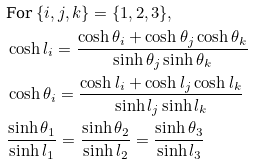<formula> <loc_0><loc_0><loc_500><loc_500>& \text {For} \ \{ i , j , k \} = \{ 1 , 2 , 3 \} , & \\ & \cosh l _ { i } = \frac { \cosh \theta _ { i } + \cosh \theta _ { j } \cosh \theta _ { k } } { \sinh \theta _ { j } \sinh \theta _ { k } } & \\ & \cosh \theta _ { i } = \frac { \cosh l _ { i } + \cosh l _ { j } \cosh l _ { k } } { \sinh l _ { j } \sinh l _ { k } } & \\ & \frac { \sinh \theta _ { 1 } } { \sinh l _ { 1 } } = \frac { \sinh \theta _ { 2 } } { \sinh l _ { 2 } } = \frac { \sinh \theta _ { 3 } } { \sinh l _ { 3 } } &</formula> 